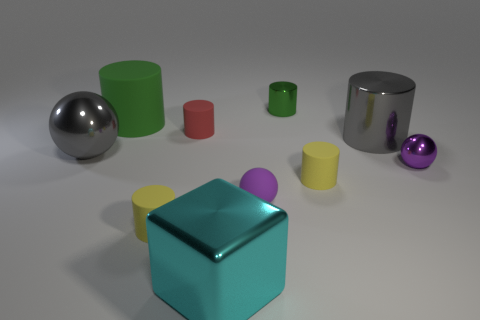Subtract all red cylinders. How many cylinders are left? 5 Subtract all large gray shiny cylinders. How many cylinders are left? 5 Subtract all red cylinders. Subtract all brown cubes. How many cylinders are left? 5 Subtract all balls. How many objects are left? 7 Subtract 0 blue cubes. How many objects are left? 10 Subtract all tiny yellow cylinders. Subtract all red objects. How many objects are left? 7 Add 8 big cyan metal objects. How many big cyan metal objects are left? 9 Add 1 large cylinders. How many large cylinders exist? 3 